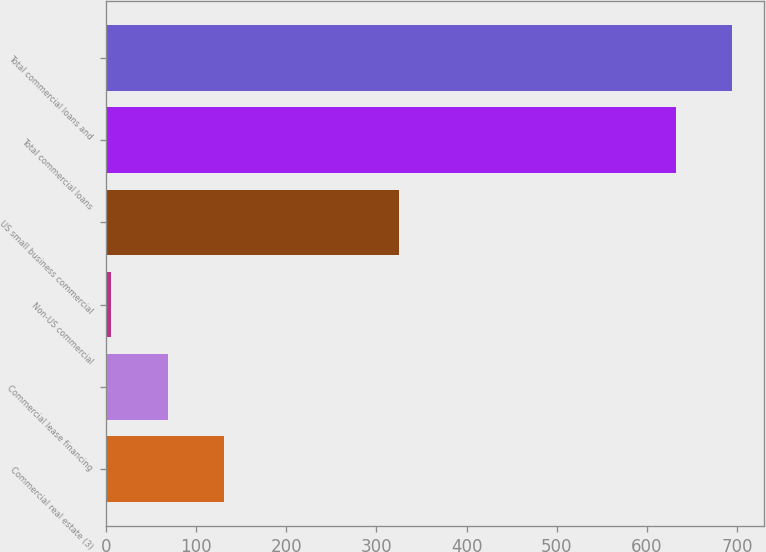Convert chart to OTSL. <chart><loc_0><loc_0><loc_500><loc_500><bar_chart><fcel>Commercial real estate (3)<fcel>Commercial lease financing<fcel>Non-US commercial<fcel>US small business commercial<fcel>Total commercial loans<fcel>Total commercial loans and<nl><fcel>131.2<fcel>68.6<fcel>6<fcel>325<fcel>632<fcel>694.6<nl></chart> 